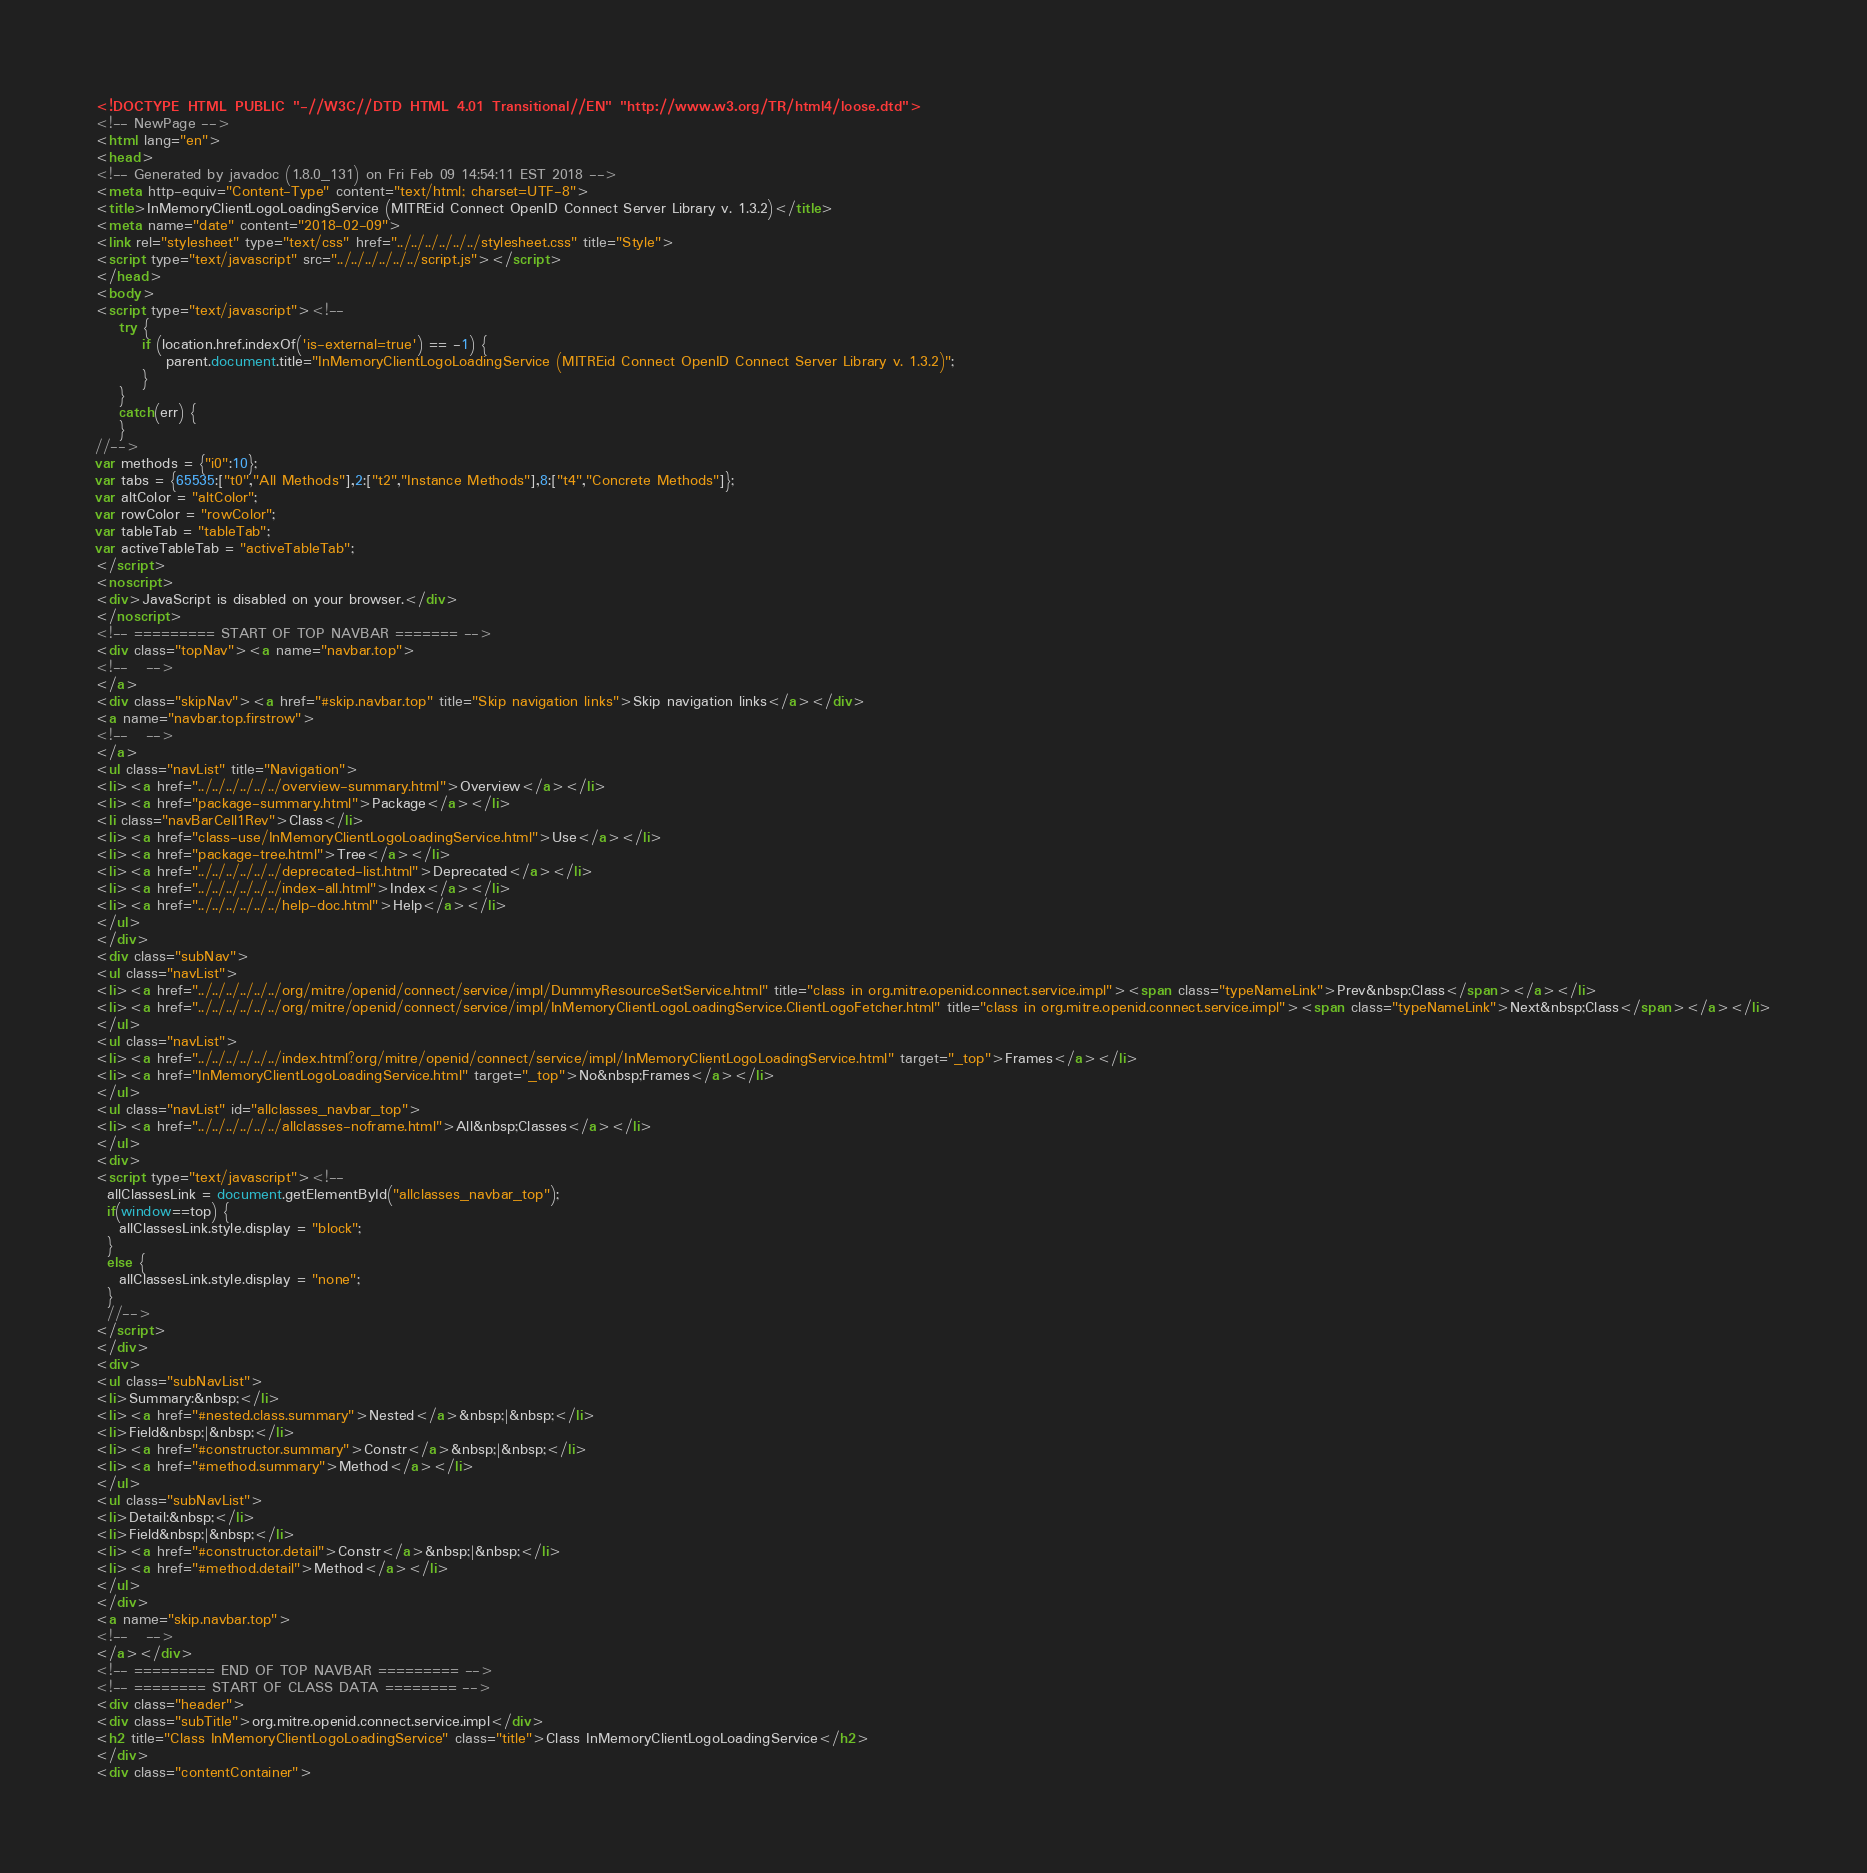Convert code to text. <code><loc_0><loc_0><loc_500><loc_500><_HTML_><!DOCTYPE HTML PUBLIC "-//W3C//DTD HTML 4.01 Transitional//EN" "http://www.w3.org/TR/html4/loose.dtd">
<!-- NewPage -->
<html lang="en">
<head>
<!-- Generated by javadoc (1.8.0_131) on Fri Feb 09 14:54:11 EST 2018 -->
<meta http-equiv="Content-Type" content="text/html; charset=UTF-8">
<title>InMemoryClientLogoLoadingService (MITREid Connect OpenID Connect Server Library v. 1.3.2)</title>
<meta name="date" content="2018-02-09">
<link rel="stylesheet" type="text/css" href="../../../../../../stylesheet.css" title="Style">
<script type="text/javascript" src="../../../../../../script.js"></script>
</head>
<body>
<script type="text/javascript"><!--
    try {
        if (location.href.indexOf('is-external=true') == -1) {
            parent.document.title="InMemoryClientLogoLoadingService (MITREid Connect OpenID Connect Server Library v. 1.3.2)";
        }
    }
    catch(err) {
    }
//-->
var methods = {"i0":10};
var tabs = {65535:["t0","All Methods"],2:["t2","Instance Methods"],8:["t4","Concrete Methods"]};
var altColor = "altColor";
var rowColor = "rowColor";
var tableTab = "tableTab";
var activeTableTab = "activeTableTab";
</script>
<noscript>
<div>JavaScript is disabled on your browser.</div>
</noscript>
<!-- ========= START OF TOP NAVBAR ======= -->
<div class="topNav"><a name="navbar.top">
<!--   -->
</a>
<div class="skipNav"><a href="#skip.navbar.top" title="Skip navigation links">Skip navigation links</a></div>
<a name="navbar.top.firstrow">
<!--   -->
</a>
<ul class="navList" title="Navigation">
<li><a href="../../../../../../overview-summary.html">Overview</a></li>
<li><a href="package-summary.html">Package</a></li>
<li class="navBarCell1Rev">Class</li>
<li><a href="class-use/InMemoryClientLogoLoadingService.html">Use</a></li>
<li><a href="package-tree.html">Tree</a></li>
<li><a href="../../../../../../deprecated-list.html">Deprecated</a></li>
<li><a href="../../../../../../index-all.html">Index</a></li>
<li><a href="../../../../../../help-doc.html">Help</a></li>
</ul>
</div>
<div class="subNav">
<ul class="navList">
<li><a href="../../../../../../org/mitre/openid/connect/service/impl/DummyResourceSetService.html" title="class in org.mitre.openid.connect.service.impl"><span class="typeNameLink">Prev&nbsp;Class</span></a></li>
<li><a href="../../../../../../org/mitre/openid/connect/service/impl/InMemoryClientLogoLoadingService.ClientLogoFetcher.html" title="class in org.mitre.openid.connect.service.impl"><span class="typeNameLink">Next&nbsp;Class</span></a></li>
</ul>
<ul class="navList">
<li><a href="../../../../../../index.html?org/mitre/openid/connect/service/impl/InMemoryClientLogoLoadingService.html" target="_top">Frames</a></li>
<li><a href="InMemoryClientLogoLoadingService.html" target="_top">No&nbsp;Frames</a></li>
</ul>
<ul class="navList" id="allclasses_navbar_top">
<li><a href="../../../../../../allclasses-noframe.html">All&nbsp;Classes</a></li>
</ul>
<div>
<script type="text/javascript"><!--
  allClassesLink = document.getElementById("allclasses_navbar_top");
  if(window==top) {
    allClassesLink.style.display = "block";
  }
  else {
    allClassesLink.style.display = "none";
  }
  //-->
</script>
</div>
<div>
<ul class="subNavList">
<li>Summary:&nbsp;</li>
<li><a href="#nested.class.summary">Nested</a>&nbsp;|&nbsp;</li>
<li>Field&nbsp;|&nbsp;</li>
<li><a href="#constructor.summary">Constr</a>&nbsp;|&nbsp;</li>
<li><a href="#method.summary">Method</a></li>
</ul>
<ul class="subNavList">
<li>Detail:&nbsp;</li>
<li>Field&nbsp;|&nbsp;</li>
<li><a href="#constructor.detail">Constr</a>&nbsp;|&nbsp;</li>
<li><a href="#method.detail">Method</a></li>
</ul>
</div>
<a name="skip.navbar.top">
<!--   -->
</a></div>
<!-- ========= END OF TOP NAVBAR ========= -->
<!-- ======== START OF CLASS DATA ======== -->
<div class="header">
<div class="subTitle">org.mitre.openid.connect.service.impl</div>
<h2 title="Class InMemoryClientLogoLoadingService" class="title">Class InMemoryClientLogoLoadingService</h2>
</div>
<div class="contentContainer"></code> 